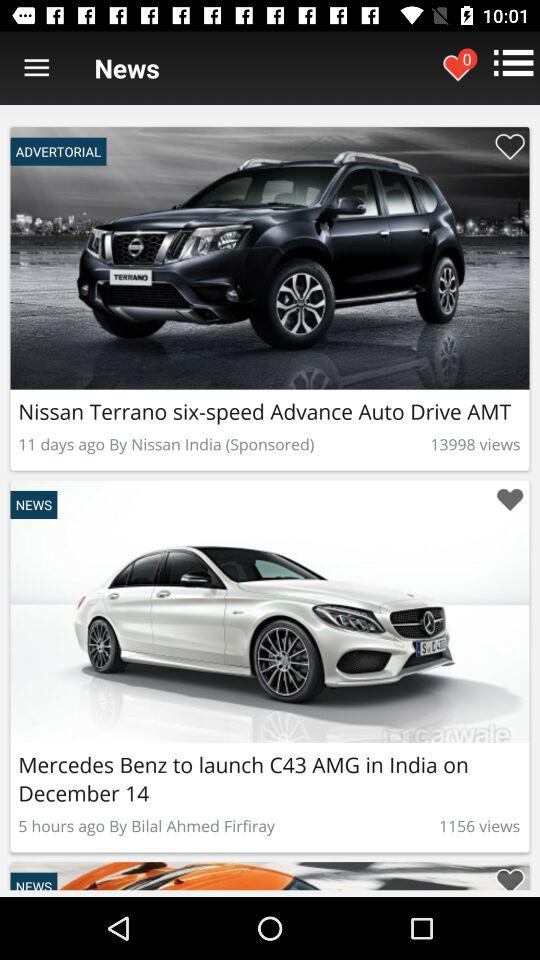By whom was the article "Nissan Terrano six-speed Advance Auto Drive AMT" published? The article was published by "Nissan India". 